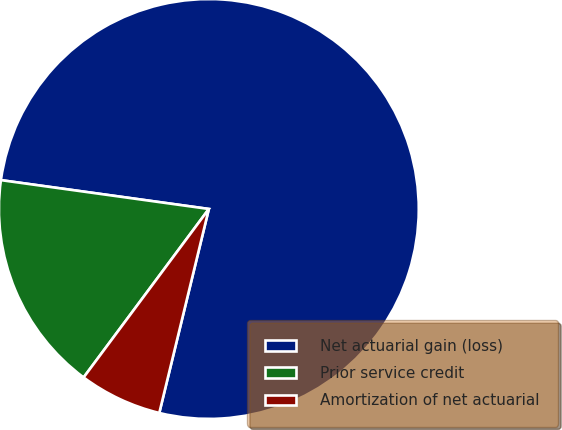Convert chart. <chart><loc_0><loc_0><loc_500><loc_500><pie_chart><fcel>Net actuarial gain (loss)<fcel>Prior service credit<fcel>Amortization of net actuarial<nl><fcel>76.6%<fcel>17.02%<fcel>6.38%<nl></chart> 